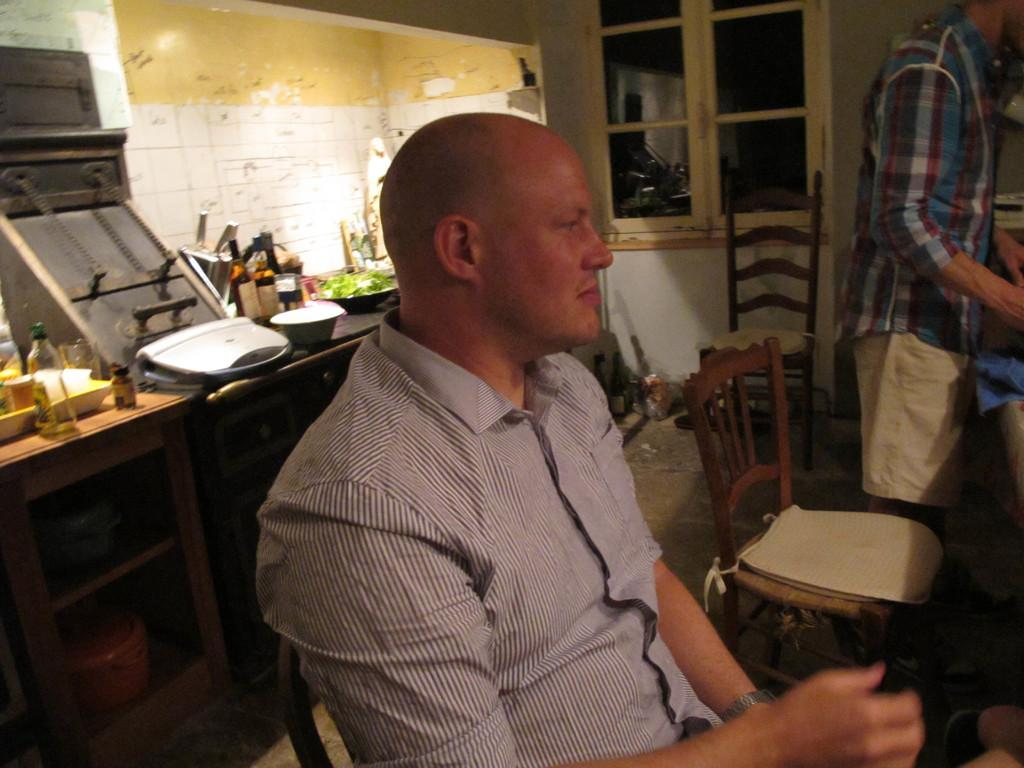What is the man in the image doing? The man is sitting in the image. Who else is present in the image? There is another person standing in the image. What can be seen in the background of the image? There are chairs, a window, a countertop with many things on it, and a wall visible in the background of the image. Is there any grass visible in the image? No, there is no grass visible in the image. Is it raining in the image? No, there is no indication of rain in the image. 